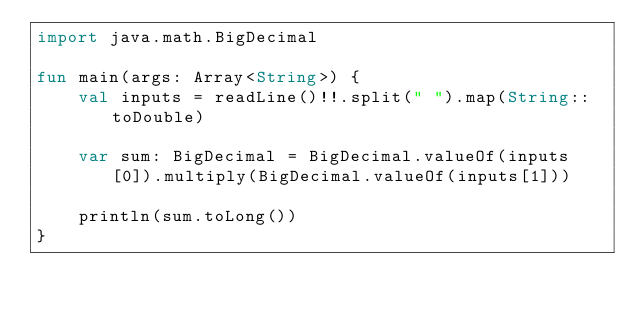<code> <loc_0><loc_0><loc_500><loc_500><_Kotlin_>import java.math.BigDecimal

fun main(args: Array<String>) {
    val inputs = readLine()!!.split(" ").map(String::toDouble)

    var sum: BigDecimal = BigDecimal.valueOf(inputs[0]).multiply(BigDecimal.valueOf(inputs[1]))

    println(sum.toLong())
}
</code> 